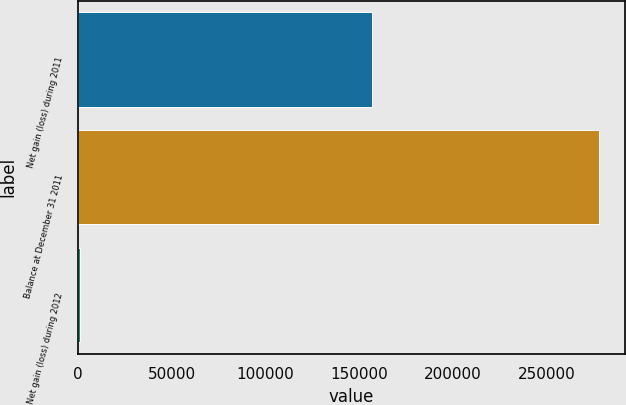Convert chart. <chart><loc_0><loc_0><loc_500><loc_500><bar_chart><fcel>Net gain (loss) during 2011<fcel>Balance at December 31 2011<fcel>Net gain (loss) during 2012<nl><fcel>156824<fcel>277716<fcel>945<nl></chart> 